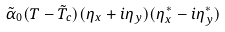Convert formula to latex. <formula><loc_0><loc_0><loc_500><loc_500>\tilde { \alpha } _ { 0 } ( T - \tilde { T } _ { c } ) ( \eta _ { x } + i \eta _ { y } ) ( \eta _ { x } ^ { * } - i \eta _ { y } ^ { * } )</formula> 